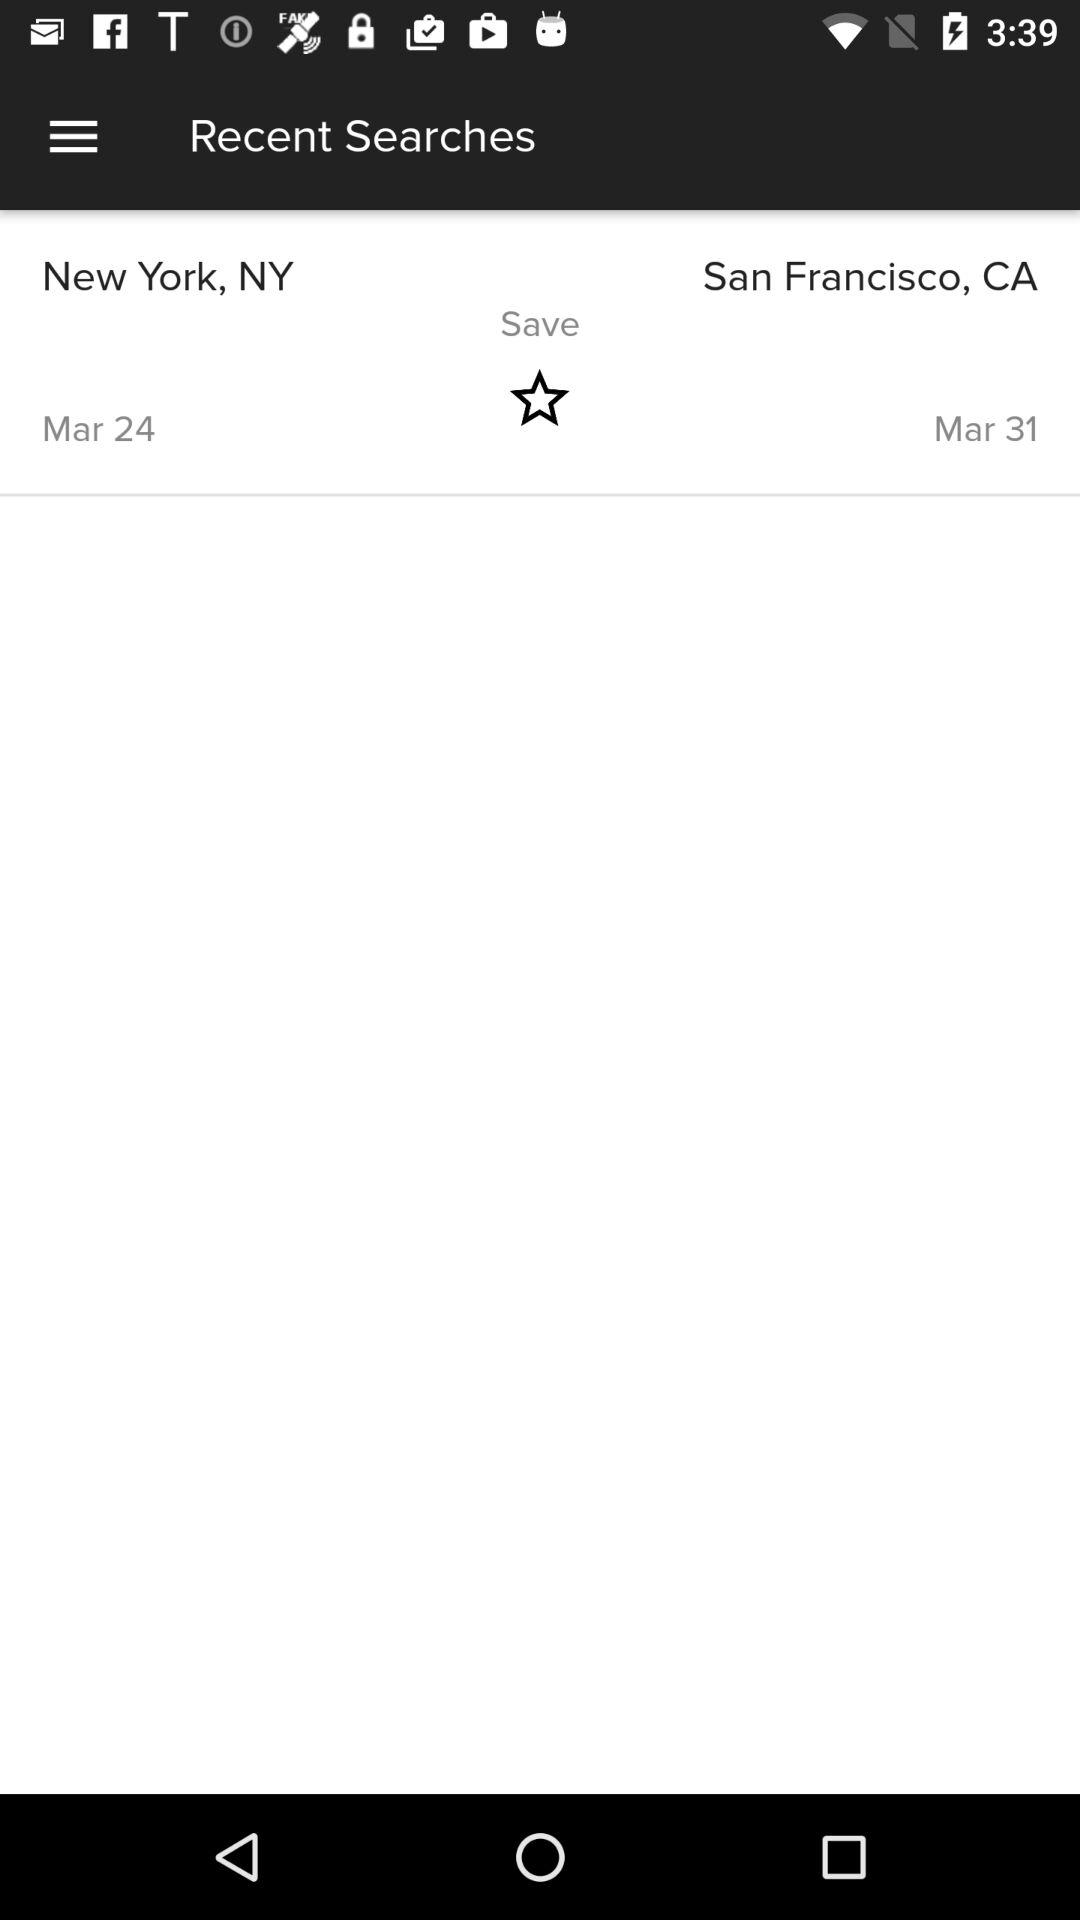What is the end location? The end location is San Francisco, CA. 